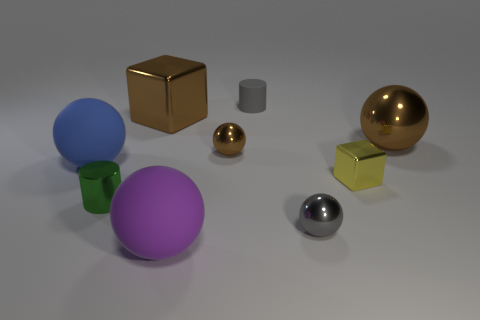Does the large sphere that is behind the big blue thing have the same color as the matte sphere that is in front of the blue ball?
Offer a very short reply. No. Is there anything else that has the same size as the gray metal sphere?
Provide a short and direct response. Yes. There is a large brown metallic cube; are there any tiny gray spheres on the left side of it?
Make the answer very short. No. How many other tiny gray objects are the same shape as the small rubber object?
Your answer should be very brief. 0. What is the color of the cube in front of the large matte sphere on the left side of the big matte ball that is to the right of the small green thing?
Ensure brevity in your answer.  Yellow. Are the tiny sphere that is on the left side of the tiny gray shiny ball and the small gray thing that is behind the brown metal cube made of the same material?
Ensure brevity in your answer.  No. How many objects are either tiny cylinders that are in front of the tiny gray matte cylinder or tiny yellow things?
Give a very brief answer. 2. What number of objects are either tiny matte cylinders or brown balls that are on the right side of the small yellow metallic block?
Provide a succinct answer. 2. How many green metallic objects have the same size as the yellow object?
Offer a very short reply. 1. Are there fewer large brown metal objects that are in front of the big brown cube than purple rubber things to the left of the big purple object?
Provide a short and direct response. No. 